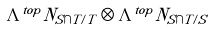<formula> <loc_0><loc_0><loc_500><loc_500>\Lambda ^ { t o p } N _ { S \cap T / T } \otimes \Lambda ^ { t o p } N _ { S \cap T / S }</formula> 